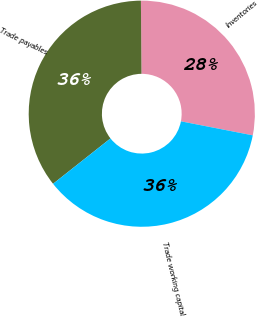<chart> <loc_0><loc_0><loc_500><loc_500><pie_chart><fcel>Inventories<fcel>Trade payables<fcel>Trade working capital<nl><fcel>28.19%<fcel>35.52%<fcel>36.29%<nl></chart> 